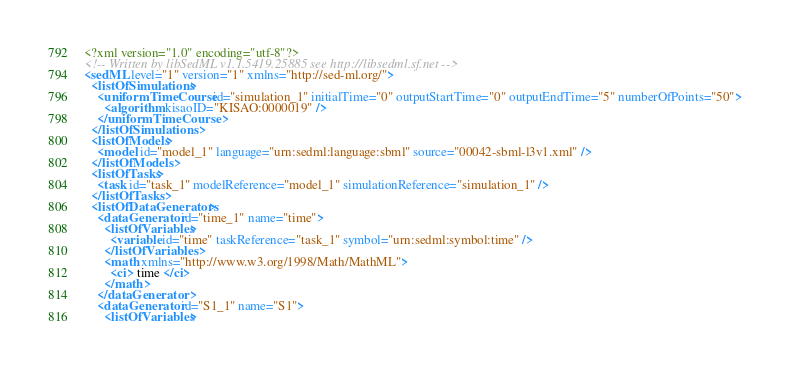Convert code to text. <code><loc_0><loc_0><loc_500><loc_500><_XML_><?xml version="1.0" encoding="utf-8"?>
<!-- Written by libSedML v1.1.5419.25885 see http://libsedml.sf.net -->
<sedML level="1" version="1" xmlns="http://sed-ml.org/">
  <listOfSimulations>
    <uniformTimeCourse id="simulation_1" initialTime="0" outputStartTime="0" outputEndTime="5" numberOfPoints="50">
      <algorithm kisaoID="KISAO:0000019" />
    </uniformTimeCourse>
  </listOfSimulations>
  <listOfModels>
    <model id="model_1" language="urn:sedml:language:sbml" source="00042-sbml-l3v1.xml" />
  </listOfModels>
  <listOfTasks>
    <task id="task_1" modelReference="model_1" simulationReference="simulation_1" />
  </listOfTasks>
  <listOfDataGenerators>
    <dataGenerator id="time_1" name="time">
      <listOfVariables>
        <variable id="time" taskReference="task_1" symbol="urn:sedml:symbol:time" />
      </listOfVariables>
      <math xmlns="http://www.w3.org/1998/Math/MathML">
        <ci> time </ci>
      </math>
    </dataGenerator>
    <dataGenerator id="S1_1" name="S1">
      <listOfVariables></code> 